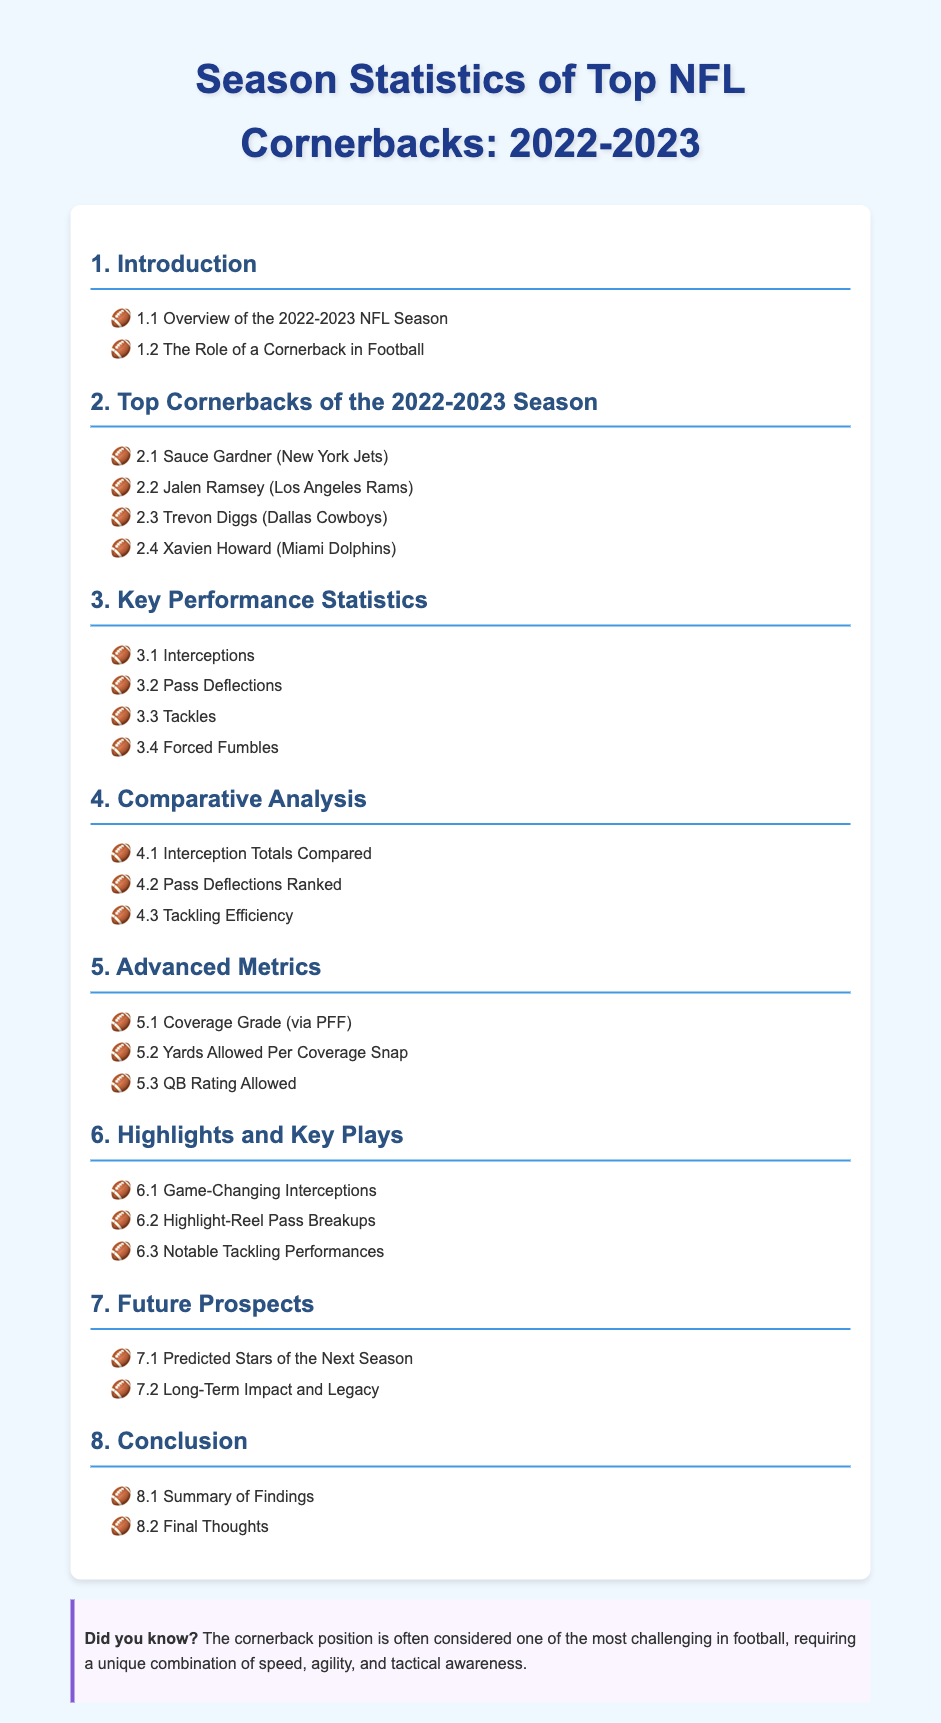What is the title of the document? The title of the document is specified at the top of the content within the <title> tag.
Answer: Season Statistics of Top NFL Cornerbacks: 2022-2023 Who is listed as the first top cornerback? The first top cornerback is mentioned in the section about top cornerbacks under section 2.
Answer: Sauce Gardner (New York Jets) How many key performance statistics categories are included? The number of categories can be found in section 3, which lists the types of performance statistics.
Answer: 4 What is the main focus of section 5? Section 5 is dedicated to advanced metrics in the statistics of cornerbacks, indicating its specialized nature.
Answer: Advanced Metrics What type of analysis is covered in section 4? Section 4 discusses comparative analysis, which indicates a focus on comparing statistics across players.
Answer: Comparative Analysis Which team does Jalen Ramsey play for? The team associated with Jalen Ramsey is mentioned in the list of top cornerbacks, specifying his current team.
Answer: Los Angeles Rams What is highlighted in the "Did you know?" section? The "Did you know?" section provides an interesting fact about the cornerback position, emphasizing its challenges.
Answer: The cornerback position is often considered one of the most challenging in football How many future prospects topics are there in section 7? The total subjects in section 7 regarding future prospects can be counted from the points listed.
Answer: 2 